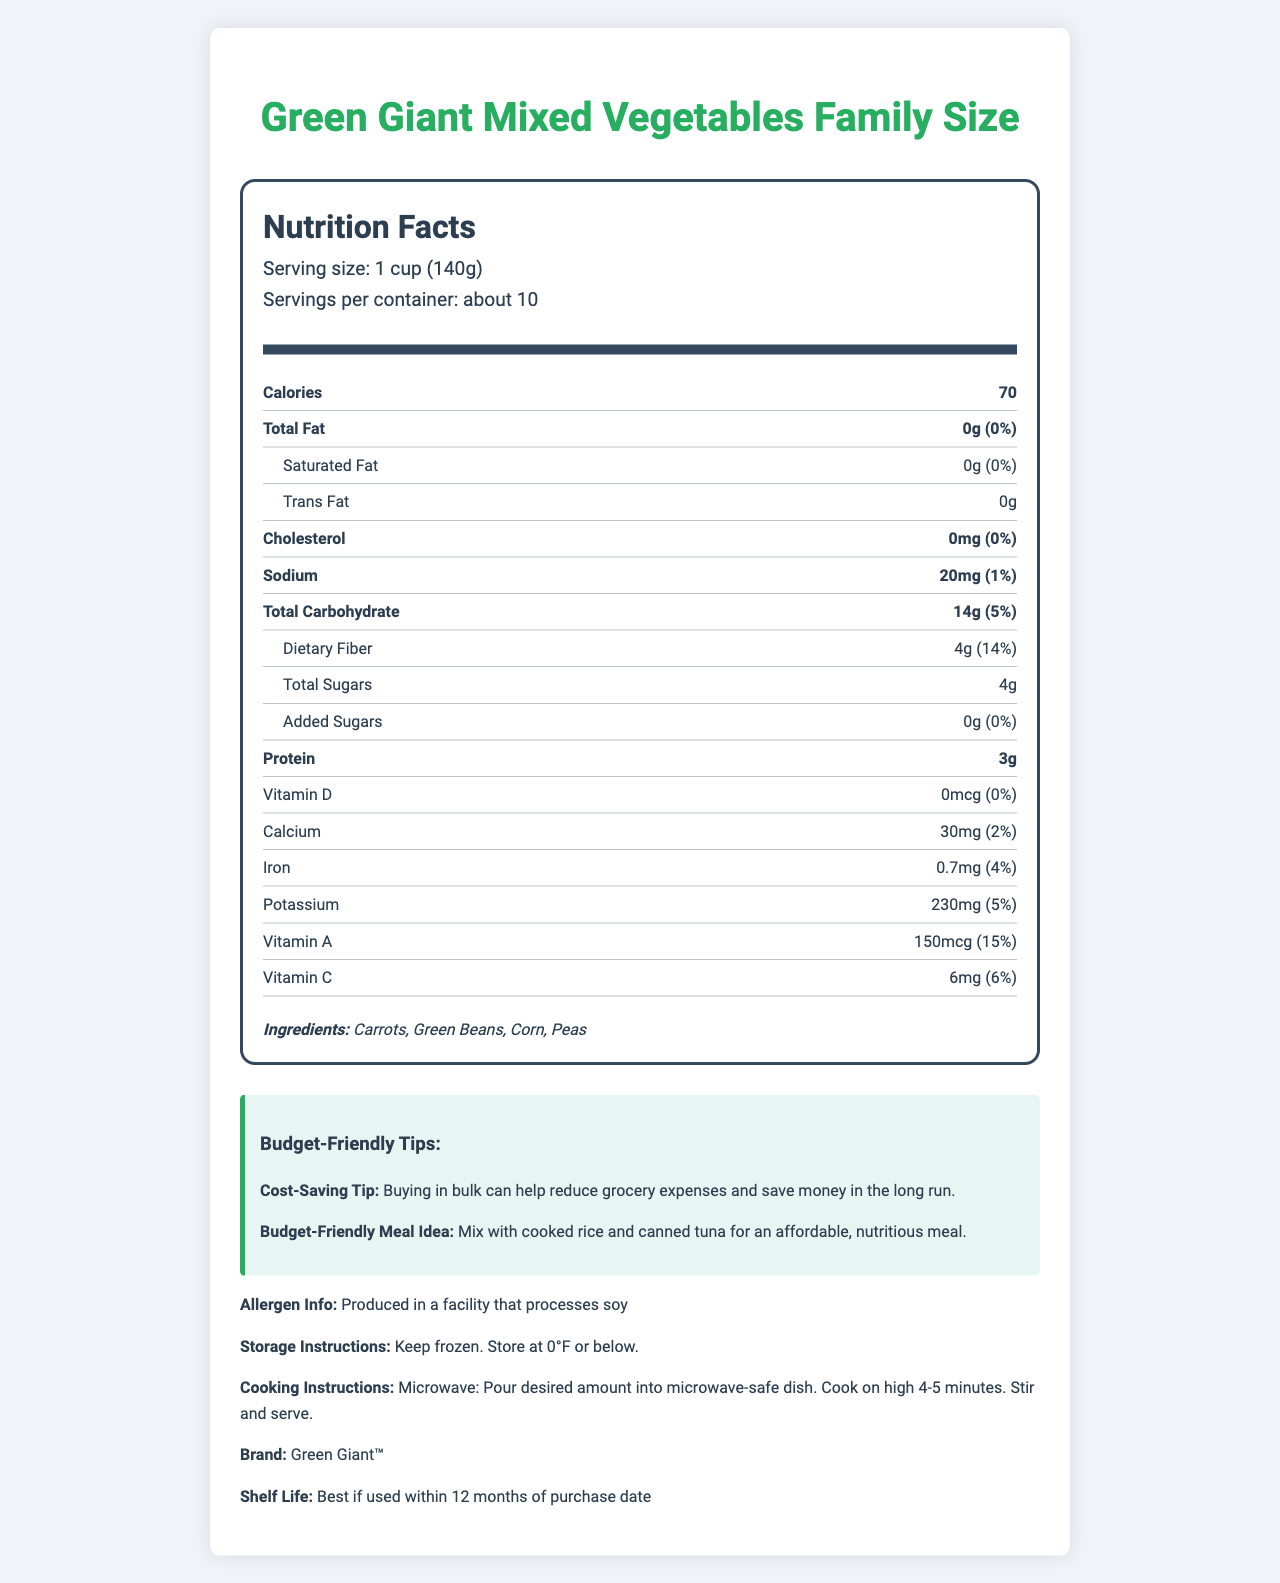What is the serving size of the Green Giant Mixed Vegetables Family Size? The serving size is explicitly listed as "1 cup (140g)" in the document.
Answer: 1 cup (140g) How many servings are there per container? The document states that there are “about 10" servings per container.
Answer: About 10 How many calories are there per serving? The number of calories per serving is directly stated as 70.
Answer: 70 What is the sodium content per serving? The sodium content per serving is listed as "20mg."
Answer: 20mg How much vitamin A is there per serving, and what percentage of the daily value does it represent? The document specifies that there is 150mcg of vitamin A per serving, which represents 15% of the daily value.
Answer: 150mcg; 15% How long should you cook the vegetables in the microwave? A. 2-3 minutes B. 4-5 minutes C. 6-7 minutes The cooking instructions indicate that you should cook the vegetables in the microwave for 4-5 minutes.
Answer: B. 4-5 minutes What are the main ingredients in the Green Giant Mixed Vegetables Family Size? A. Carrots, Green Beans, Corn, Peas B. Broccoli, Cauliflower, Spinach C. Carrots, Spinach, Broccoli The ingredients listed are Carrots, Green Beans, Corn, and Peas.
Answer: A. Carrots, Green Beans, Corn, Peas Is this product a good source of dietary fiber? The product contains 4g of dietary fiber, which represents 14% of the daily value, indicating it is a good source of dietary fiber.
Answer: Yes Summarize the main idea of this document. The detailed description covers various aspects, such as nutritional content, brand information, ingredients, and cost-saving tips, to give an overview of what the product offers.
Answer: The document provides detailed nutritional information for Green Giant Mixed Vegetables Family Size, including serving size, calories, nutrients, ingredients, allergen information, storage instructions, cooking instructions, and additional budget-friendly tips. Can this product be stored at room temperature? The storage instructions clearly state that the product should be kept frozen and stored at 0°F or below.
Answer: No Is this product produced in a facility that processes soy? The allergen information indicates that the product is produced in a facility that processes soy.
Answer: Yes What is the total amount of protein per serving? The document states that there are 3g of protein per serving.
Answer: 3g What is the daily value percentage of calcium in one serving? The document specifies that one serving provides 2% of the daily value for calcium.
Answer: 2% How much-added sugar is in one serving of this product? A. 5g B. 2g C. 0g D. 3g The document states that there are 0g of added sugars in one serving.
Answer: C. 0g What is the shelf life of the Green Giant Mixed Vegetables Family Size? The document mentions that the product is best if used within 12 months of the purchase date.
Answer: Best if used within 12 months of purchase date What is the main nutritional benefit of buying this product for a budget-friendly meal? This insight helps to understand that buying in bulk, particularly this product, can contribute to cost-effective meal planning.
Answer: The product offers a cost-saving tip by suggesting a nutritious meal of mixed vegetables combined with cooked rice and canned tuna, which is affordable and nutritious. 